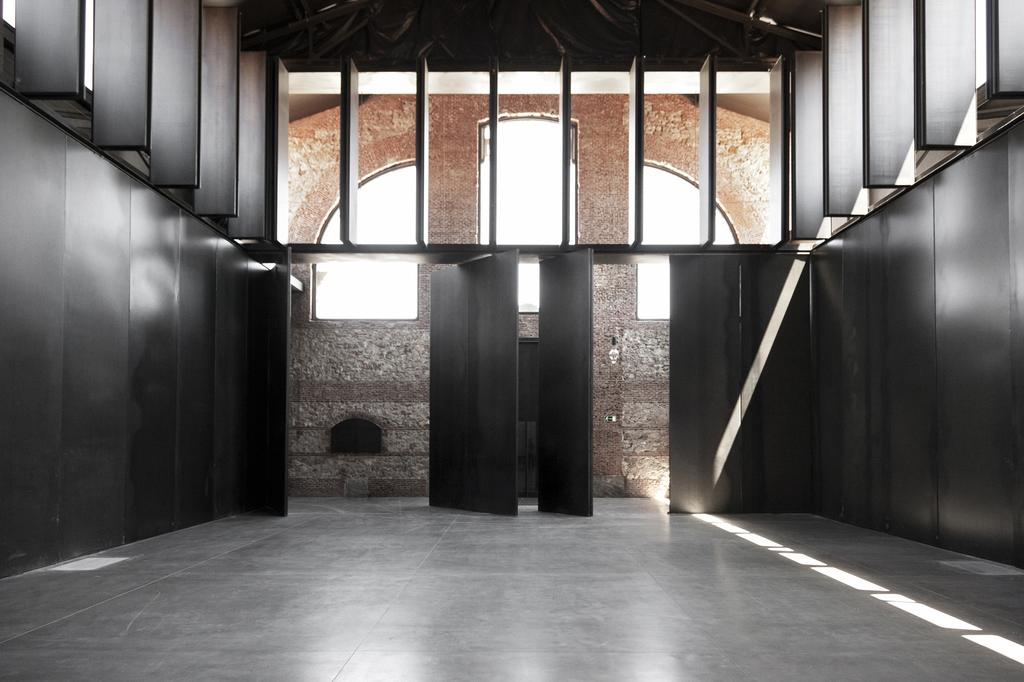What is located on the left side of the image? There is a wall on the left side of the image. What is located on the right side of the image? There is a wall on the right side of the image. What can be seen in the image besides the walls? There are doors, a brick wall in the background, and glass windows visible in the image. What type of house is being discussed in the meeting in the image? There is no meeting or house present in the image; it only features walls, doors, a brick wall, and glass windows. 